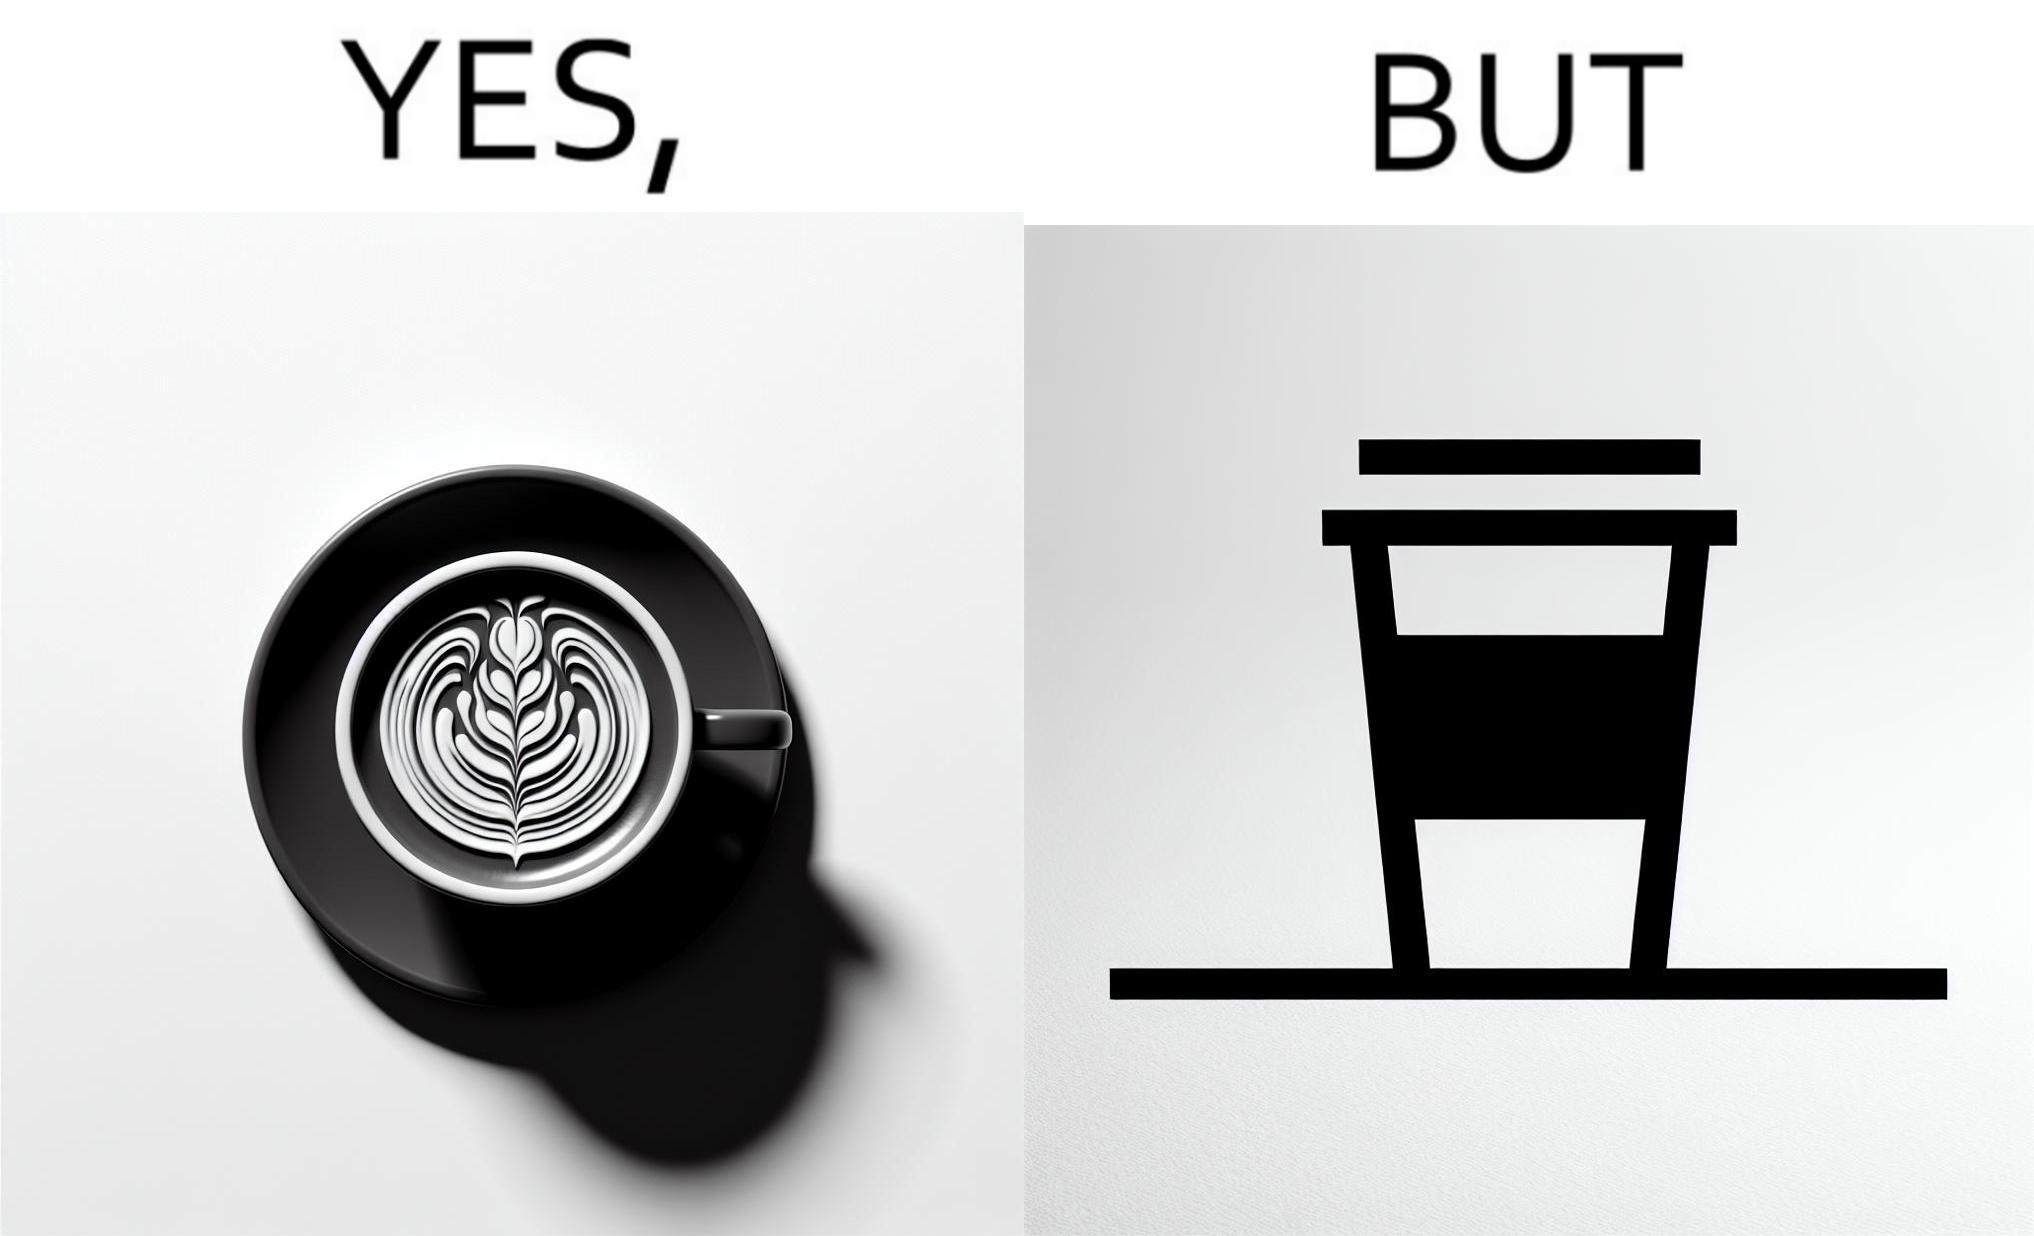What is shown in the left half versus the right half of this image? In the left part of the image: It is a cup of coffee with latte art In the right part of the image: It is a cup of coffee with its lid on top 